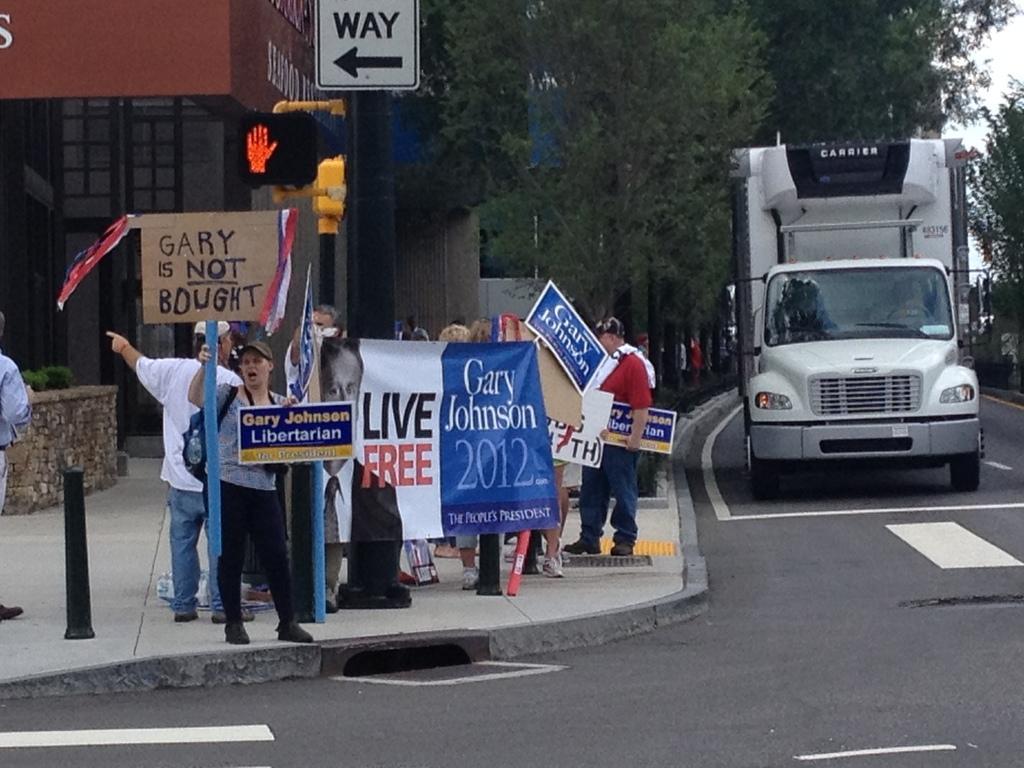In one or two sentences, can you explain what this image depicts? In this picture we can see some people standing and holding boards, there is a banner here, on the right side there is a vehicle traveling on the road, we can see a pole and a board here, in the background there is a building, we can see some trees here, there is the sky at the right top of the picture. 